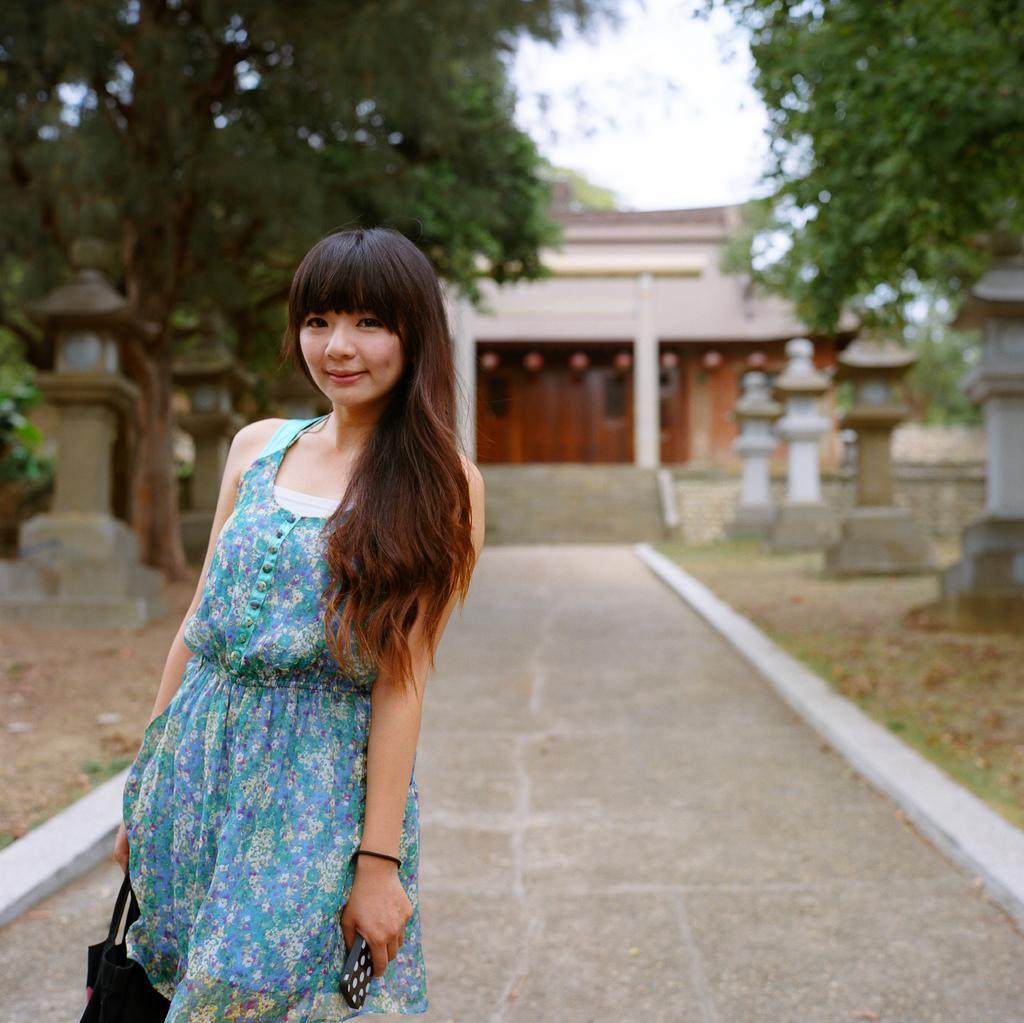Can you describe this image briefly? In the background we can see the sky, house. In this picture we can see trees, pillars, grass and the pathway. We can see a woman standing, she is carrying a bag and mobile. She is smiling. 